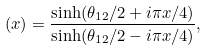<formula> <loc_0><loc_0><loc_500><loc_500>( x ) = \frac { \sinh ( \theta _ { 1 2 } / 2 + i \pi x / 4 ) } { \sinh ( \theta _ { 1 2 } / 2 - i \pi x / 4 ) } ,</formula> 